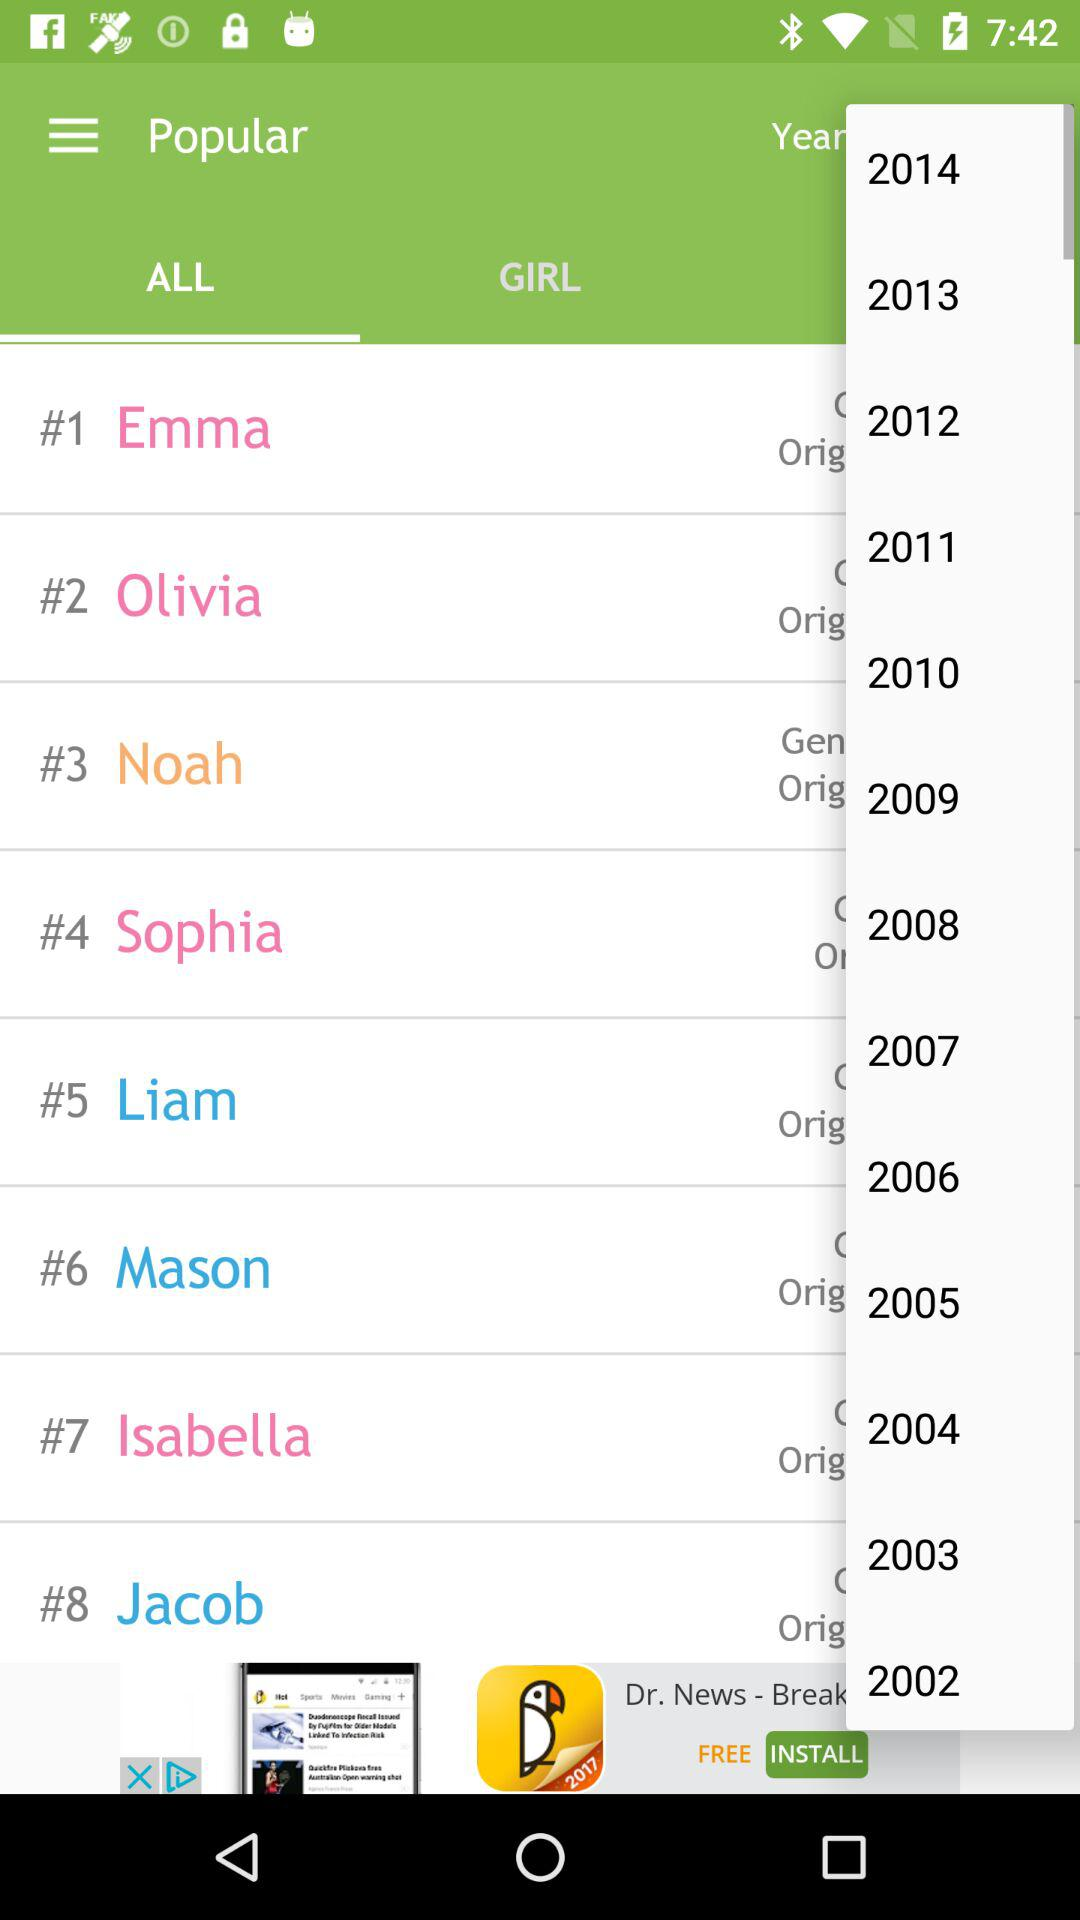Which tab has been selected? The selected tab is "ALL". 